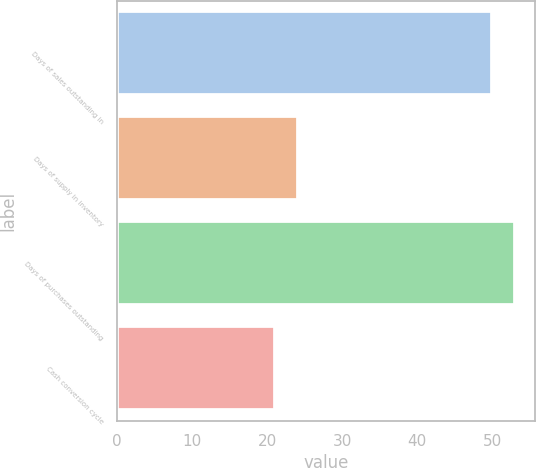Convert chart. <chart><loc_0><loc_0><loc_500><loc_500><bar_chart><fcel>Days of sales outstanding in<fcel>Days of supply in inventory<fcel>Days of purchases outstanding<fcel>Cash conversion cycle<nl><fcel>50<fcel>24.1<fcel>53.1<fcel>21<nl></chart> 